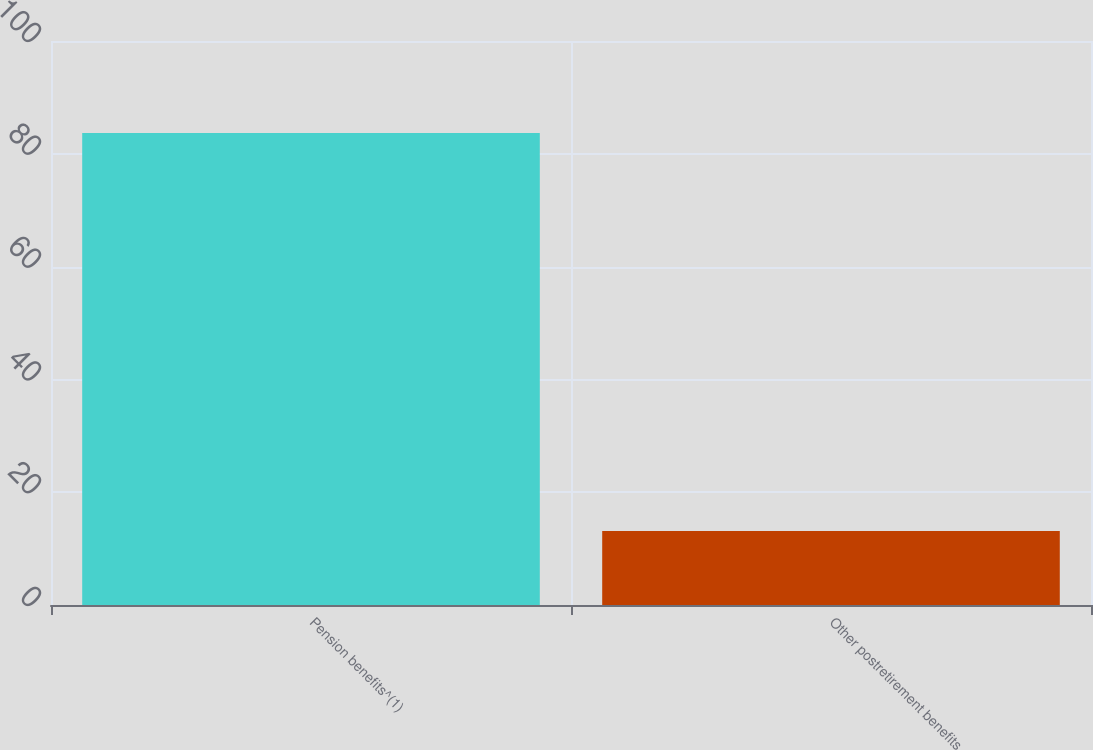Convert chart to OTSL. <chart><loc_0><loc_0><loc_500><loc_500><bar_chart><fcel>Pension benefits^(1)<fcel>Other postretirement benefits<nl><fcel>83.7<fcel>13.1<nl></chart> 